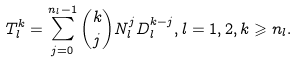<formula> <loc_0><loc_0><loc_500><loc_500>T _ { l } ^ { k } = \sum _ { j = 0 } ^ { n _ { l } - 1 } \binom { k } { j } N _ { l } ^ { j } D _ { l } ^ { k - j } , l = 1 , 2 , k \geqslant n _ { l } .</formula> 